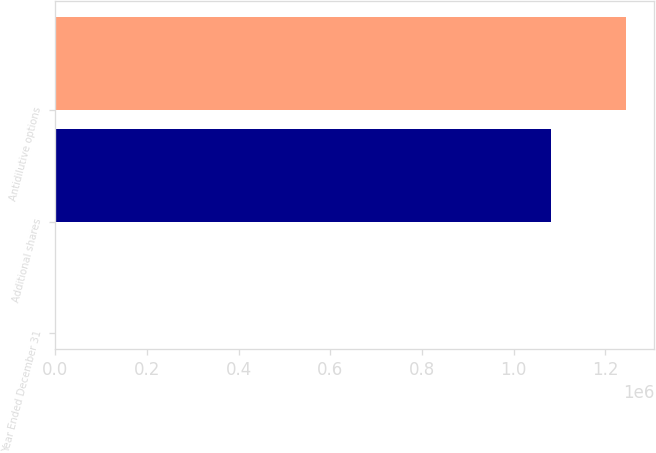Convert chart to OTSL. <chart><loc_0><loc_0><loc_500><loc_500><bar_chart><fcel>Year Ended December 31<fcel>Additional shares<fcel>Antidilutive options<nl><fcel>2011<fcel>1.082e+06<fcel>1.2447e+06<nl></chart> 